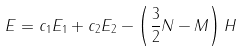Convert formula to latex. <formula><loc_0><loc_0><loc_500><loc_500>E = c _ { 1 } E _ { 1 } + c _ { 2 } E _ { 2 } - \left ( \frac { 3 } { 2 } N - M \right ) H</formula> 